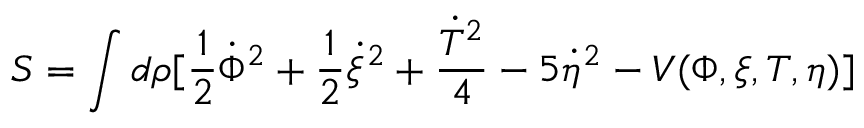<formula> <loc_0><loc_0><loc_500><loc_500>S = \int d \rho [ \frac { 1 } { 2 } \dot { \Phi } ^ { 2 } + \frac { 1 } { 2 } \dot { \xi } ^ { 2 } + \frac { \dot { T } ^ { 2 } } { 4 } - 5 \dot { \eta } ^ { 2 } - V ( \Phi , \xi , T , \eta ) ]</formula> 